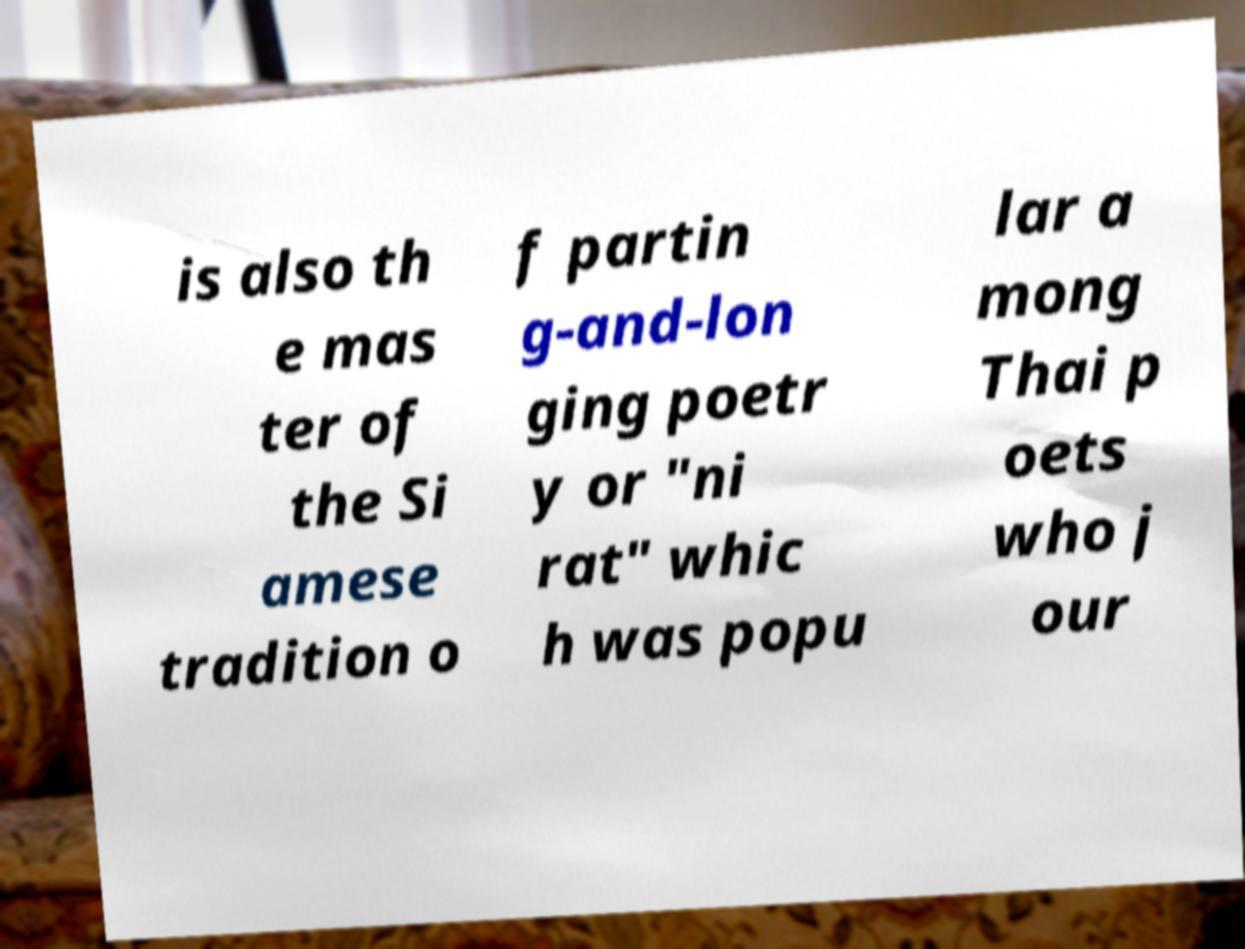There's text embedded in this image that I need extracted. Can you transcribe it verbatim? is also th e mas ter of the Si amese tradition o f partin g-and-lon ging poetr y or "ni rat" whic h was popu lar a mong Thai p oets who j our 